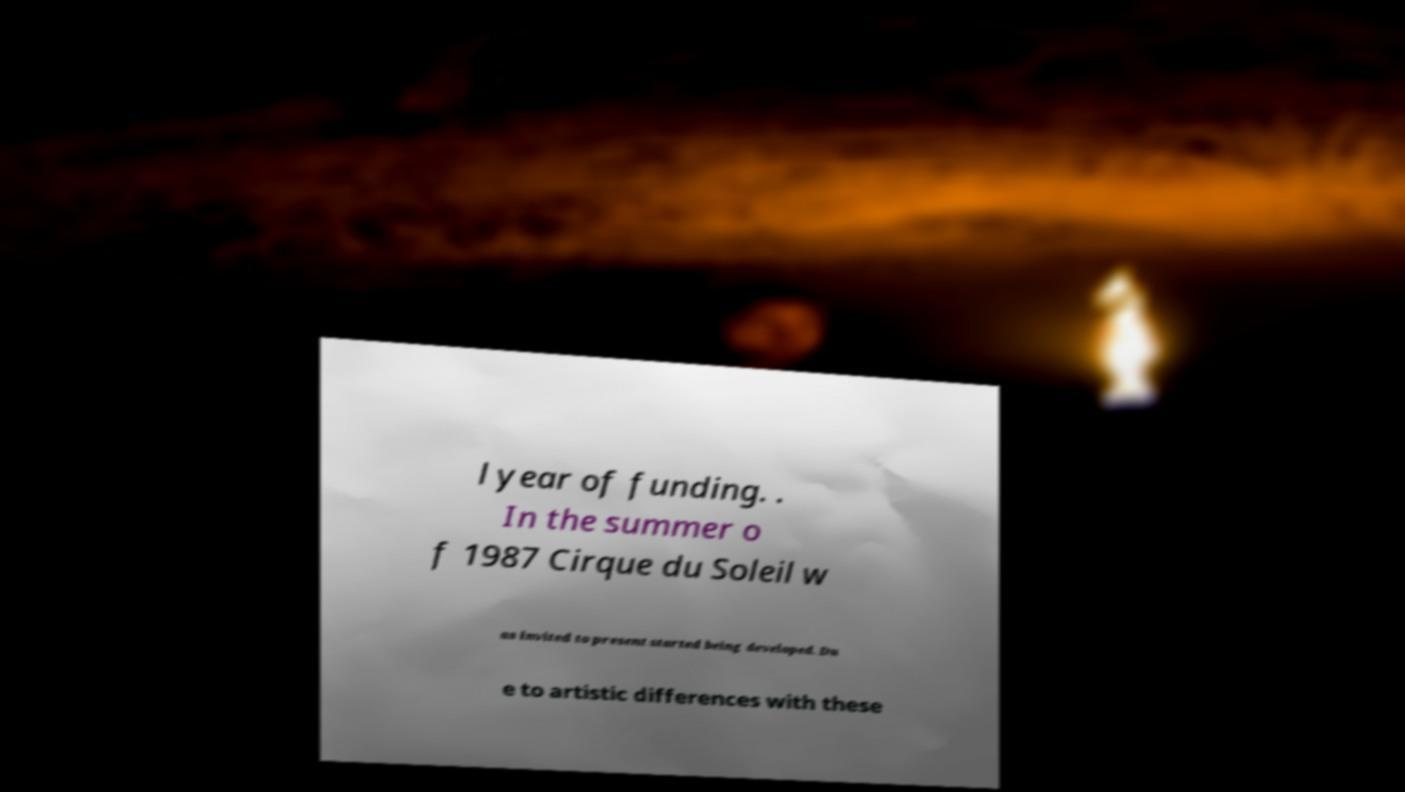Please read and relay the text visible in this image. What does it say? l year of funding. . In the summer o f 1987 Cirque du Soleil w as invited to present started being developed. Du e to artistic differences with these 